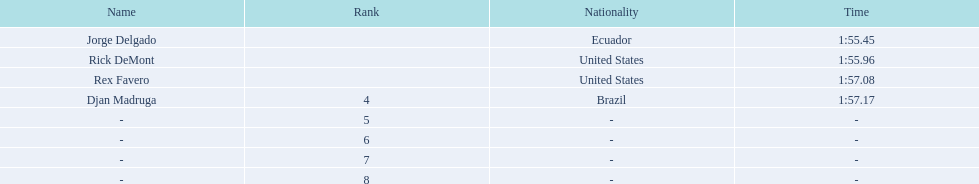What is the average time? 1:56.42. 